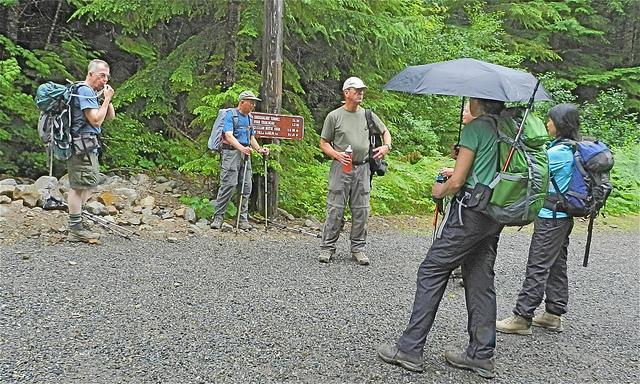How many people?
Give a very brief answer. 5. How many people are there?
Give a very brief answer. 5. How many backpacks are in the photo?
Give a very brief answer. 3. How many of the train doors are green?
Give a very brief answer. 0. 